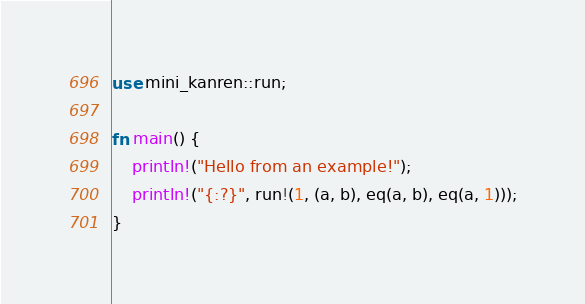Convert code to text. <code><loc_0><loc_0><loc_500><loc_500><_Rust_>use mini_kanren::run;

fn main() {
    println!("Hello from an example!");
    println!("{:?}", run!(1, (a, b), eq(a, b), eq(a, 1)));
}
</code> 